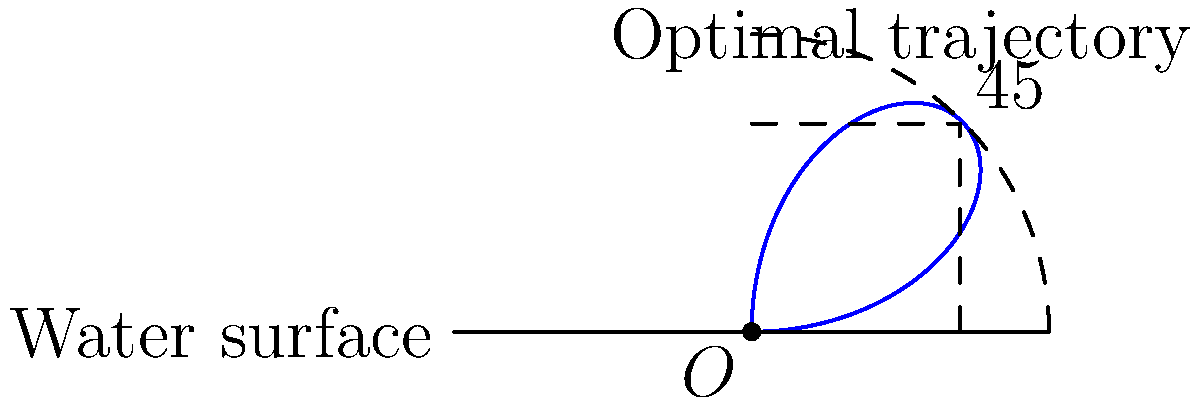In platform diving, the takeoff angle significantly impacts the dive's execution and scoring. Consider a polar coordinate system where the origin represents the edge of the diving platform, and the angle is measured from the horizontal. The trajectory of an ideal dive can be modeled by the equation $r = 10 \sin(2\theta)$, where $r$ is in meters and $\theta$ is in radians. What is the optimal takeoff angle for maximizing the diver's height and rotation potential? To find the optimal takeoff angle, we need to determine where the function $r = 10 \sin(2\theta)$ reaches its maximum value. This occurs when $\sin(2\theta)$ is at its maximum.

Step 1: The sine function reaches its maximum value of 1 when its argument is $\frac{\pi}{2}$ (or 90°).

Step 2: Set up the equation:
$$2\theta = \frac{\pi}{2}$$

Step 3: Solve for $\theta$:
$$\theta = \frac{\pi}{4}$$

Step 4: Convert radians to degrees:
$$\frac{\pi}{4} \text{ radians} = 45°$$

The optimal takeoff angle is 45° from the horizontal. This angle provides the best balance between vertical height and horizontal distance, allowing the diver to achieve maximum height for rotations while still traveling far enough from the platform for a safe entry into the water.

In diving coaching, this 45° angle is often referred to as the "sweet spot" for takeoffs, as it optimizes the diver's trajectory for most types of dives from the platform.
Answer: 45° 